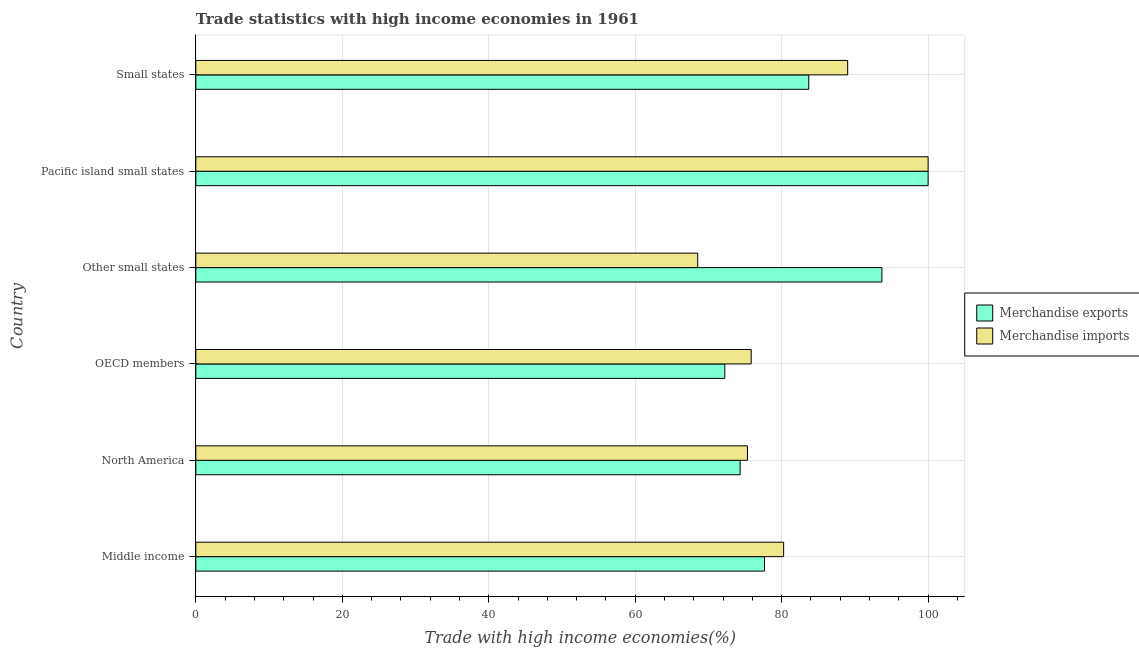How many different coloured bars are there?
Provide a succinct answer. 2. Are the number of bars on each tick of the Y-axis equal?
Give a very brief answer. Yes. How many bars are there on the 6th tick from the top?
Keep it short and to the point. 2. What is the label of the 2nd group of bars from the top?
Offer a very short reply. Pacific island small states. Across all countries, what is the minimum merchandise imports?
Give a very brief answer. 68.53. In which country was the merchandise exports maximum?
Ensure brevity in your answer.  Pacific island small states. In which country was the merchandise imports minimum?
Provide a succinct answer. Other small states. What is the total merchandise imports in the graph?
Offer a very short reply. 488.98. What is the difference between the merchandise imports in Pacific island small states and that in Small states?
Offer a terse response. 10.99. What is the difference between the merchandise exports in OECD members and the merchandise imports in North America?
Your answer should be very brief. -3.09. What is the average merchandise imports per country?
Ensure brevity in your answer.  81.5. What is the difference between the merchandise imports and merchandise exports in OECD members?
Provide a short and direct response. 3.6. In how many countries, is the merchandise exports greater than 68 %?
Make the answer very short. 6. What is the ratio of the merchandise exports in Other small states to that in Pacific island small states?
Ensure brevity in your answer.  0.94. Is the merchandise imports in Middle income less than that in Small states?
Offer a terse response. Yes. What is the difference between the highest and the second highest merchandise imports?
Provide a short and direct response. 10.99. What is the difference between the highest and the lowest merchandise imports?
Provide a short and direct response. 31.47. In how many countries, is the merchandise exports greater than the average merchandise exports taken over all countries?
Offer a very short reply. 3. How many bars are there?
Your answer should be very brief. 12. What is the difference between two consecutive major ticks on the X-axis?
Ensure brevity in your answer.  20. Are the values on the major ticks of X-axis written in scientific E-notation?
Provide a short and direct response. No. Does the graph contain any zero values?
Make the answer very short. No. How many legend labels are there?
Keep it short and to the point. 2. What is the title of the graph?
Ensure brevity in your answer.  Trade statistics with high income economies in 1961. What is the label or title of the X-axis?
Your answer should be compact. Trade with high income economies(%). What is the Trade with high income economies(%) in Merchandise exports in Middle income?
Provide a succinct answer. 77.66. What is the Trade with high income economies(%) in Merchandise imports in Middle income?
Your response must be concise. 80.27. What is the Trade with high income economies(%) in Merchandise exports in North America?
Offer a very short reply. 74.33. What is the Trade with high income economies(%) of Merchandise imports in North America?
Keep it short and to the point. 75.33. What is the Trade with high income economies(%) of Merchandise exports in OECD members?
Your answer should be compact. 72.24. What is the Trade with high income economies(%) in Merchandise imports in OECD members?
Offer a very short reply. 75.84. What is the Trade with high income economies(%) of Merchandise exports in Other small states?
Your answer should be very brief. 93.69. What is the Trade with high income economies(%) of Merchandise imports in Other small states?
Offer a very short reply. 68.53. What is the Trade with high income economies(%) of Merchandise exports in Pacific island small states?
Make the answer very short. 100. What is the Trade with high income economies(%) of Merchandise imports in Pacific island small states?
Offer a very short reply. 100. What is the Trade with high income economies(%) of Merchandise exports in Small states?
Offer a very short reply. 83.7. What is the Trade with high income economies(%) in Merchandise imports in Small states?
Provide a succinct answer. 89.01. Across all countries, what is the minimum Trade with high income economies(%) of Merchandise exports?
Make the answer very short. 72.24. Across all countries, what is the minimum Trade with high income economies(%) in Merchandise imports?
Make the answer very short. 68.53. What is the total Trade with high income economies(%) of Merchandise exports in the graph?
Offer a very short reply. 501.61. What is the total Trade with high income economies(%) in Merchandise imports in the graph?
Provide a succinct answer. 488.98. What is the difference between the Trade with high income economies(%) in Merchandise exports in Middle income and that in North America?
Offer a terse response. 3.33. What is the difference between the Trade with high income economies(%) in Merchandise imports in Middle income and that in North America?
Provide a short and direct response. 4.94. What is the difference between the Trade with high income economies(%) in Merchandise exports in Middle income and that in OECD members?
Your answer should be compact. 5.42. What is the difference between the Trade with high income economies(%) of Merchandise imports in Middle income and that in OECD members?
Provide a short and direct response. 4.43. What is the difference between the Trade with high income economies(%) of Merchandise exports in Middle income and that in Other small states?
Your answer should be very brief. -16.03. What is the difference between the Trade with high income economies(%) in Merchandise imports in Middle income and that in Other small states?
Give a very brief answer. 11.73. What is the difference between the Trade with high income economies(%) in Merchandise exports in Middle income and that in Pacific island small states?
Give a very brief answer. -22.34. What is the difference between the Trade with high income economies(%) in Merchandise imports in Middle income and that in Pacific island small states?
Make the answer very short. -19.73. What is the difference between the Trade with high income economies(%) in Merchandise exports in Middle income and that in Small states?
Give a very brief answer. -6.04. What is the difference between the Trade with high income economies(%) of Merchandise imports in Middle income and that in Small states?
Offer a terse response. -8.74. What is the difference between the Trade with high income economies(%) in Merchandise exports in North America and that in OECD members?
Your answer should be compact. 2.09. What is the difference between the Trade with high income economies(%) of Merchandise imports in North America and that in OECD members?
Offer a terse response. -0.51. What is the difference between the Trade with high income economies(%) of Merchandise exports in North America and that in Other small states?
Your response must be concise. -19.35. What is the difference between the Trade with high income economies(%) in Merchandise imports in North America and that in Other small states?
Offer a terse response. 6.79. What is the difference between the Trade with high income economies(%) in Merchandise exports in North America and that in Pacific island small states?
Ensure brevity in your answer.  -25.67. What is the difference between the Trade with high income economies(%) in Merchandise imports in North America and that in Pacific island small states?
Make the answer very short. -24.67. What is the difference between the Trade with high income economies(%) in Merchandise exports in North America and that in Small states?
Provide a short and direct response. -9.37. What is the difference between the Trade with high income economies(%) of Merchandise imports in North America and that in Small states?
Your answer should be very brief. -13.69. What is the difference between the Trade with high income economies(%) in Merchandise exports in OECD members and that in Other small states?
Make the answer very short. -21.45. What is the difference between the Trade with high income economies(%) in Merchandise imports in OECD members and that in Other small states?
Provide a short and direct response. 7.3. What is the difference between the Trade with high income economies(%) of Merchandise exports in OECD members and that in Pacific island small states?
Your answer should be very brief. -27.76. What is the difference between the Trade with high income economies(%) of Merchandise imports in OECD members and that in Pacific island small states?
Make the answer very short. -24.16. What is the difference between the Trade with high income economies(%) of Merchandise exports in OECD members and that in Small states?
Make the answer very short. -11.46. What is the difference between the Trade with high income economies(%) in Merchandise imports in OECD members and that in Small states?
Offer a terse response. -13.17. What is the difference between the Trade with high income economies(%) of Merchandise exports in Other small states and that in Pacific island small states?
Make the answer very short. -6.31. What is the difference between the Trade with high income economies(%) of Merchandise imports in Other small states and that in Pacific island small states?
Your response must be concise. -31.47. What is the difference between the Trade with high income economies(%) of Merchandise exports in Other small states and that in Small states?
Your answer should be very brief. 9.99. What is the difference between the Trade with high income economies(%) of Merchandise imports in Other small states and that in Small states?
Provide a short and direct response. -20.48. What is the difference between the Trade with high income economies(%) of Merchandise exports in Pacific island small states and that in Small states?
Offer a terse response. 16.3. What is the difference between the Trade with high income economies(%) in Merchandise imports in Pacific island small states and that in Small states?
Provide a succinct answer. 10.99. What is the difference between the Trade with high income economies(%) of Merchandise exports in Middle income and the Trade with high income economies(%) of Merchandise imports in North America?
Provide a short and direct response. 2.33. What is the difference between the Trade with high income economies(%) in Merchandise exports in Middle income and the Trade with high income economies(%) in Merchandise imports in OECD members?
Give a very brief answer. 1.82. What is the difference between the Trade with high income economies(%) in Merchandise exports in Middle income and the Trade with high income economies(%) in Merchandise imports in Other small states?
Offer a very short reply. 9.12. What is the difference between the Trade with high income economies(%) in Merchandise exports in Middle income and the Trade with high income economies(%) in Merchandise imports in Pacific island small states?
Provide a short and direct response. -22.34. What is the difference between the Trade with high income economies(%) in Merchandise exports in Middle income and the Trade with high income economies(%) in Merchandise imports in Small states?
Your answer should be compact. -11.35. What is the difference between the Trade with high income economies(%) in Merchandise exports in North America and the Trade with high income economies(%) in Merchandise imports in OECD members?
Your answer should be very brief. -1.51. What is the difference between the Trade with high income economies(%) in Merchandise exports in North America and the Trade with high income economies(%) in Merchandise imports in Other small states?
Give a very brief answer. 5.8. What is the difference between the Trade with high income economies(%) of Merchandise exports in North America and the Trade with high income economies(%) of Merchandise imports in Pacific island small states?
Provide a succinct answer. -25.67. What is the difference between the Trade with high income economies(%) in Merchandise exports in North America and the Trade with high income economies(%) in Merchandise imports in Small states?
Provide a short and direct response. -14.68. What is the difference between the Trade with high income economies(%) in Merchandise exports in OECD members and the Trade with high income economies(%) in Merchandise imports in Other small states?
Your answer should be very brief. 3.7. What is the difference between the Trade with high income economies(%) of Merchandise exports in OECD members and the Trade with high income economies(%) of Merchandise imports in Pacific island small states?
Your response must be concise. -27.76. What is the difference between the Trade with high income economies(%) in Merchandise exports in OECD members and the Trade with high income economies(%) in Merchandise imports in Small states?
Your answer should be compact. -16.77. What is the difference between the Trade with high income economies(%) of Merchandise exports in Other small states and the Trade with high income economies(%) of Merchandise imports in Pacific island small states?
Ensure brevity in your answer.  -6.31. What is the difference between the Trade with high income economies(%) in Merchandise exports in Other small states and the Trade with high income economies(%) in Merchandise imports in Small states?
Your answer should be very brief. 4.67. What is the difference between the Trade with high income economies(%) in Merchandise exports in Pacific island small states and the Trade with high income economies(%) in Merchandise imports in Small states?
Provide a succinct answer. 10.99. What is the average Trade with high income economies(%) of Merchandise exports per country?
Your answer should be very brief. 83.6. What is the average Trade with high income economies(%) of Merchandise imports per country?
Your answer should be compact. 81.5. What is the difference between the Trade with high income economies(%) of Merchandise exports and Trade with high income economies(%) of Merchandise imports in Middle income?
Make the answer very short. -2.61. What is the difference between the Trade with high income economies(%) of Merchandise exports and Trade with high income economies(%) of Merchandise imports in North America?
Your answer should be compact. -1. What is the difference between the Trade with high income economies(%) in Merchandise exports and Trade with high income economies(%) in Merchandise imports in OECD members?
Provide a succinct answer. -3.6. What is the difference between the Trade with high income economies(%) of Merchandise exports and Trade with high income economies(%) of Merchandise imports in Other small states?
Your answer should be compact. 25.15. What is the difference between the Trade with high income economies(%) in Merchandise exports and Trade with high income economies(%) in Merchandise imports in Pacific island small states?
Offer a very short reply. 0. What is the difference between the Trade with high income economies(%) of Merchandise exports and Trade with high income economies(%) of Merchandise imports in Small states?
Provide a short and direct response. -5.31. What is the ratio of the Trade with high income economies(%) in Merchandise exports in Middle income to that in North America?
Ensure brevity in your answer.  1.04. What is the ratio of the Trade with high income economies(%) in Merchandise imports in Middle income to that in North America?
Your answer should be compact. 1.07. What is the ratio of the Trade with high income economies(%) in Merchandise exports in Middle income to that in OECD members?
Make the answer very short. 1.07. What is the ratio of the Trade with high income economies(%) of Merchandise imports in Middle income to that in OECD members?
Your response must be concise. 1.06. What is the ratio of the Trade with high income economies(%) of Merchandise exports in Middle income to that in Other small states?
Offer a terse response. 0.83. What is the ratio of the Trade with high income economies(%) of Merchandise imports in Middle income to that in Other small states?
Offer a terse response. 1.17. What is the ratio of the Trade with high income economies(%) of Merchandise exports in Middle income to that in Pacific island small states?
Your response must be concise. 0.78. What is the ratio of the Trade with high income economies(%) of Merchandise imports in Middle income to that in Pacific island small states?
Keep it short and to the point. 0.8. What is the ratio of the Trade with high income economies(%) in Merchandise exports in Middle income to that in Small states?
Your answer should be compact. 0.93. What is the ratio of the Trade with high income economies(%) in Merchandise imports in Middle income to that in Small states?
Provide a short and direct response. 0.9. What is the ratio of the Trade with high income economies(%) in Merchandise exports in North America to that in OECD members?
Your response must be concise. 1.03. What is the ratio of the Trade with high income economies(%) in Merchandise imports in North America to that in OECD members?
Make the answer very short. 0.99. What is the ratio of the Trade with high income economies(%) of Merchandise exports in North America to that in Other small states?
Your answer should be compact. 0.79. What is the ratio of the Trade with high income economies(%) in Merchandise imports in North America to that in Other small states?
Provide a succinct answer. 1.1. What is the ratio of the Trade with high income economies(%) in Merchandise exports in North America to that in Pacific island small states?
Make the answer very short. 0.74. What is the ratio of the Trade with high income economies(%) in Merchandise imports in North America to that in Pacific island small states?
Your answer should be very brief. 0.75. What is the ratio of the Trade with high income economies(%) in Merchandise exports in North America to that in Small states?
Provide a short and direct response. 0.89. What is the ratio of the Trade with high income economies(%) in Merchandise imports in North America to that in Small states?
Provide a short and direct response. 0.85. What is the ratio of the Trade with high income economies(%) in Merchandise exports in OECD members to that in Other small states?
Keep it short and to the point. 0.77. What is the ratio of the Trade with high income economies(%) in Merchandise imports in OECD members to that in Other small states?
Make the answer very short. 1.11. What is the ratio of the Trade with high income economies(%) of Merchandise exports in OECD members to that in Pacific island small states?
Your response must be concise. 0.72. What is the ratio of the Trade with high income economies(%) in Merchandise imports in OECD members to that in Pacific island small states?
Keep it short and to the point. 0.76. What is the ratio of the Trade with high income economies(%) of Merchandise exports in OECD members to that in Small states?
Ensure brevity in your answer.  0.86. What is the ratio of the Trade with high income economies(%) in Merchandise imports in OECD members to that in Small states?
Keep it short and to the point. 0.85. What is the ratio of the Trade with high income economies(%) in Merchandise exports in Other small states to that in Pacific island small states?
Ensure brevity in your answer.  0.94. What is the ratio of the Trade with high income economies(%) in Merchandise imports in Other small states to that in Pacific island small states?
Ensure brevity in your answer.  0.69. What is the ratio of the Trade with high income economies(%) in Merchandise exports in Other small states to that in Small states?
Make the answer very short. 1.12. What is the ratio of the Trade with high income economies(%) of Merchandise imports in Other small states to that in Small states?
Your answer should be very brief. 0.77. What is the ratio of the Trade with high income economies(%) in Merchandise exports in Pacific island small states to that in Small states?
Ensure brevity in your answer.  1.19. What is the ratio of the Trade with high income economies(%) in Merchandise imports in Pacific island small states to that in Small states?
Provide a short and direct response. 1.12. What is the difference between the highest and the second highest Trade with high income economies(%) of Merchandise exports?
Ensure brevity in your answer.  6.31. What is the difference between the highest and the second highest Trade with high income economies(%) of Merchandise imports?
Offer a terse response. 10.99. What is the difference between the highest and the lowest Trade with high income economies(%) of Merchandise exports?
Your answer should be compact. 27.76. What is the difference between the highest and the lowest Trade with high income economies(%) in Merchandise imports?
Your answer should be very brief. 31.47. 